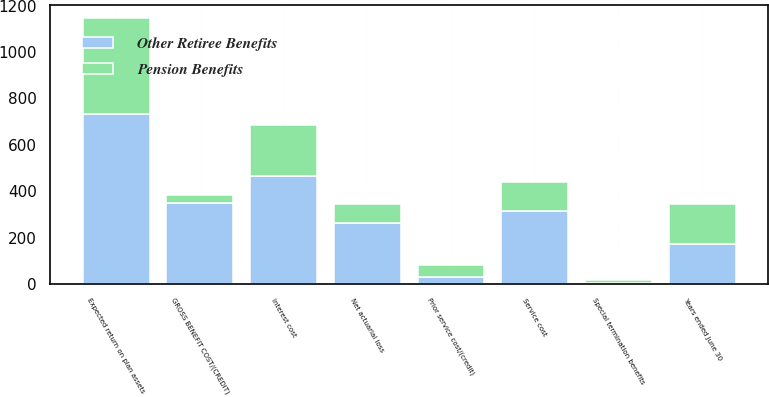Convert chart to OTSL. <chart><loc_0><loc_0><loc_500><loc_500><stacked_bar_chart><ecel><fcel>Years ended June 30<fcel>Service cost<fcel>Interest cost<fcel>Expected return on plan assets<fcel>Prior service cost/(credit)<fcel>Net actuarial loss<fcel>Special termination benefits<fcel>GROSS BENEFIT COST/(CREDIT)<nl><fcel>Other Retiree Benefits<fcel>171.5<fcel>314<fcel>466<fcel>731<fcel>29<fcel>265<fcel>6<fcel>349<nl><fcel>Pension Benefits<fcel>171.5<fcel>124<fcel>219<fcel>416<fcel>52<fcel>78<fcel>12<fcel>35<nl></chart> 